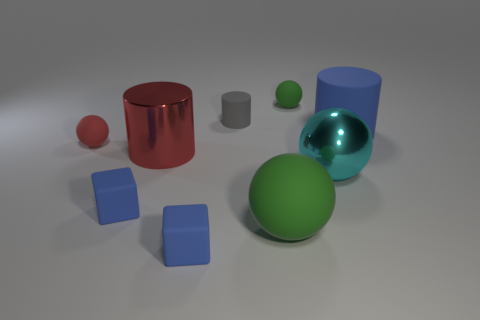There is a cyan sphere that is the same size as the blue matte cylinder; what material is it?
Ensure brevity in your answer.  Metal. There is a large thing in front of the large metal sphere; is there a small blue block right of it?
Provide a succinct answer. No. What number of other objects are the same color as the metallic cylinder?
Offer a terse response. 1. The cyan sphere has what size?
Give a very brief answer. Large. Are any gray rubber cubes visible?
Keep it short and to the point. No. Is the number of cyan balls that are right of the tiny rubber cylinder greater than the number of big matte balls right of the big green matte sphere?
Keep it short and to the point. Yes. The thing that is to the right of the small green rubber object and in front of the small red ball is made of what material?
Provide a succinct answer. Metal. Is the shape of the big red object the same as the small gray object?
Your answer should be very brief. Yes. Is there any other thing that is the same size as the red shiny cylinder?
Offer a terse response. Yes. What number of metal cylinders are to the right of the large blue rubber cylinder?
Provide a short and direct response. 0. 